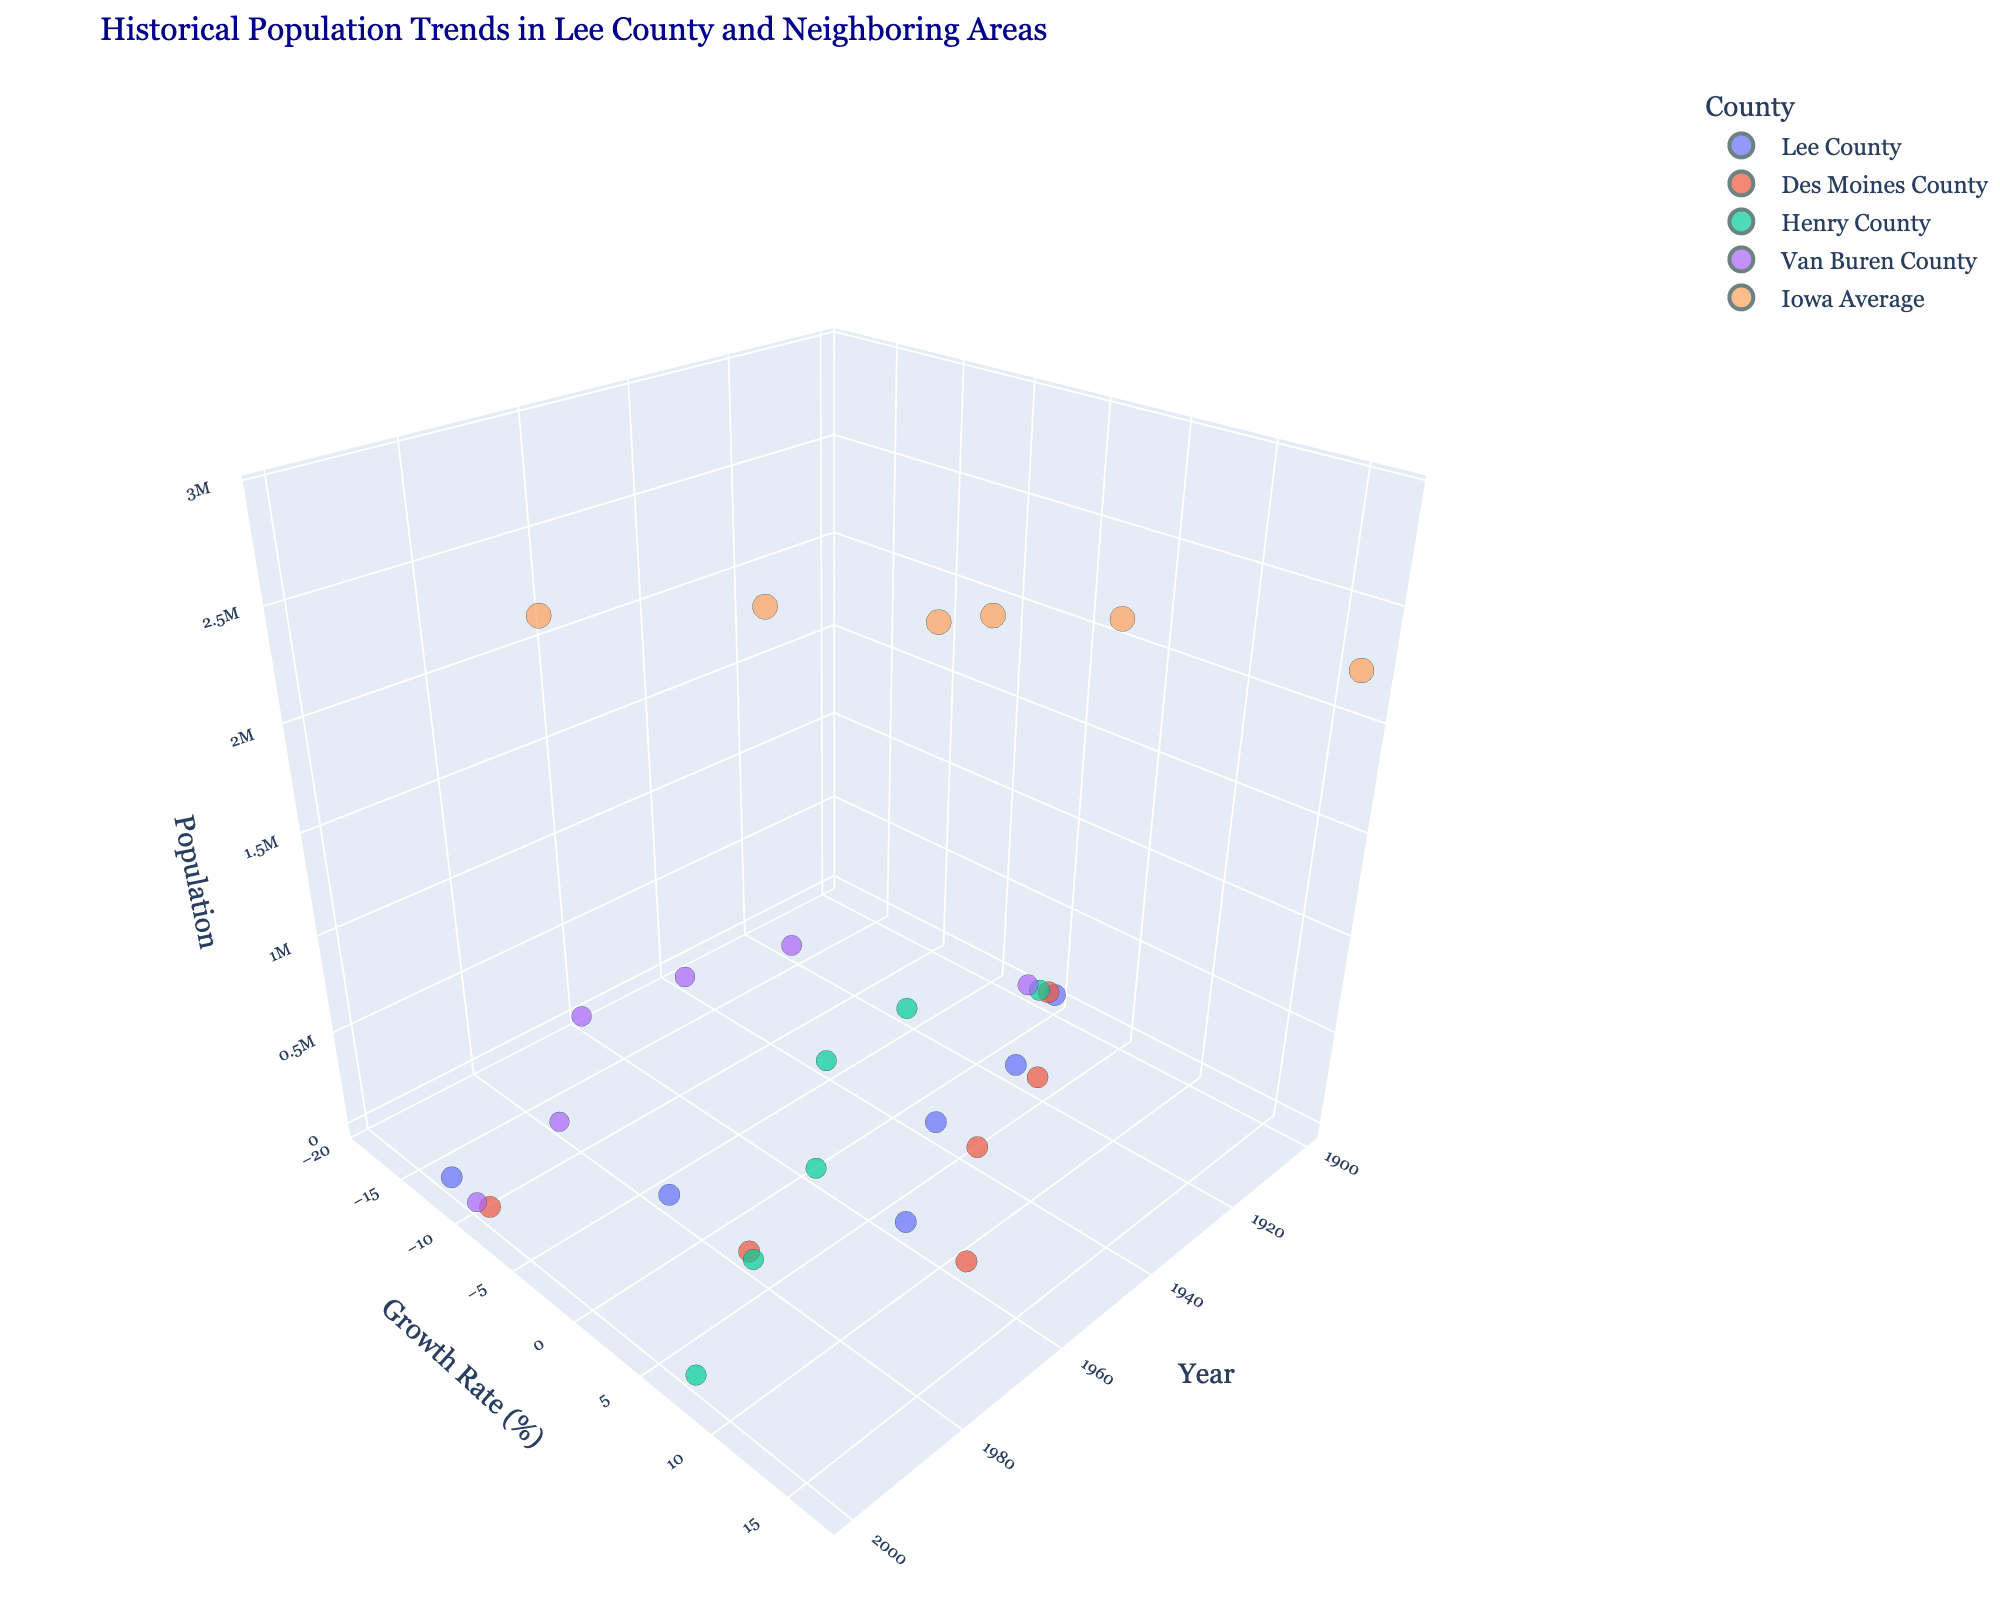What is the title of the plot? The title is typically displayed prominently at the top of the plot. Here, it reads "Historical Population Trends in Lee County and Neighboring Areas".
Answer: Historical Population Trends in Lee County and Neighboring Areas How many counties are represented in the plot? By examining the color legend or the hover information, we can count the distinct counties mentioned in the plot. We see "Lee County", "Des Moines County", "Henry County", "Van Buren County", and "Iowa Average".
Answer: 5 Which county had the highest population in the year 1960? Looking at the 1960 markers on the z-axis (population), we observe the data points and identify the tallest one. "Des Moines County" has the highest population at 44,605.
Answer: Des Moines County How does the population growth rate of Lee County in 1920 compare to Van Buren County in the same year? We find the markers for Lee County and Van Buren County in 1920 and compare their y-axis (growth rate). Lee County shows a growth rate of 2.9%, whereas Van Buren County shows -15.6%.
Answer: Lee County had a higher growth rate What is the population and growth rate of Iowa Average in the year 2000? By locating the marker for Iowa Average in 2000, we use the hover information or the position on the axes. The population is 2,926,324 and the growth rate is 0.4%.
Answer: Population: 2,926,324, Growth Rate: 0.4% How did the population of Lee County change from 1900 to 2000? Observing the z-axis positions for Lee County in 1900 and 2000, we see the population changed from 38,687 to 38,052. To determine the change: 38,052 - 38,687 = -635.
Answer: Decreased by 635 Which county experienced the most significant decline in population growth rate over time? By comparing the slope of the lines or the differences in growth rates, particularly the largest negative changes, Van Buren County shows a continuous decline to -18.9% in 1960 and -11.8% in 1980.
Answer: Van Buren County Did any county besides Iowa Average show consistent population growth throughout the years? We analyze the plot for each county except Iowa Average, checking consecutive increases in population for each. No county shows consistent growth without periods of decline.
Answer: No In what year did Des Moines County have the largest increase in population? Finding the year-to-year change in Des Moines County's z-axis markers, we see the largest increase from 1940 (39,917) to 1960 (44,605), a difference of 4,688.
Answer: 1960 Which year had the highest overall population for the state of Iowa (Iowa Average)? Reviewing the positions of Iowa Average markers along the z-axis, the peak occurs in 1960 with a population of 2,757,537.
Answer: 1960 